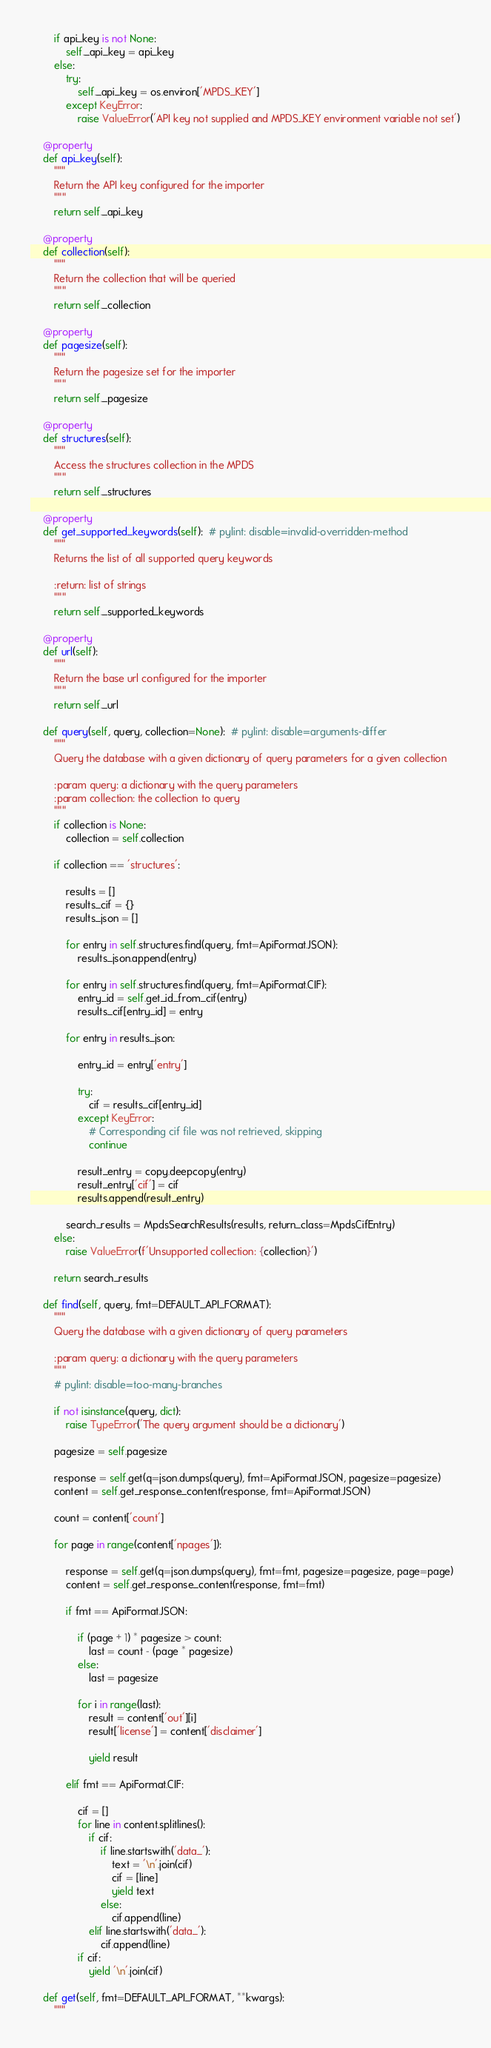<code> <loc_0><loc_0><loc_500><loc_500><_Python_>
        if api_key is not None:
            self._api_key = api_key
        else:
            try:
                self._api_key = os.environ['MPDS_KEY']
            except KeyError:
                raise ValueError('API key not supplied and MPDS_KEY environment variable not set')

    @property
    def api_key(self):
        """
        Return the API key configured for the importer
        """
        return self._api_key

    @property
    def collection(self):
        """
        Return the collection that will be queried
        """
        return self._collection

    @property
    def pagesize(self):
        """
        Return the pagesize set for the importer
        """
        return self._pagesize

    @property
    def structures(self):
        """
        Access the structures collection in the MPDS
        """
        return self._structures

    @property
    def get_supported_keywords(self):  # pylint: disable=invalid-overridden-method
        """
        Returns the list of all supported query keywords

        :return: list of strings
        """
        return self._supported_keywords

    @property
    def url(self):
        """
        Return the base url configured for the importer
        """
        return self._url

    def query(self, query, collection=None):  # pylint: disable=arguments-differ
        """
        Query the database with a given dictionary of query parameters for a given collection

        :param query: a dictionary with the query parameters
        :param collection: the collection to query
        """
        if collection is None:
            collection = self.collection

        if collection == 'structures':

            results = []
            results_cif = {}
            results_json = []

            for entry in self.structures.find(query, fmt=ApiFormat.JSON):
                results_json.append(entry)

            for entry in self.structures.find(query, fmt=ApiFormat.CIF):
                entry_id = self.get_id_from_cif(entry)
                results_cif[entry_id] = entry

            for entry in results_json:

                entry_id = entry['entry']

                try:
                    cif = results_cif[entry_id]
                except KeyError:
                    # Corresponding cif file was not retrieved, skipping
                    continue

                result_entry = copy.deepcopy(entry)
                result_entry['cif'] = cif
                results.append(result_entry)

            search_results = MpdsSearchResults(results, return_class=MpdsCifEntry)
        else:
            raise ValueError(f'Unsupported collection: {collection}')

        return search_results

    def find(self, query, fmt=DEFAULT_API_FORMAT):
        """
        Query the database with a given dictionary of query parameters

        :param query: a dictionary with the query parameters
        """
        # pylint: disable=too-many-branches

        if not isinstance(query, dict):
            raise TypeError('The query argument should be a dictionary')

        pagesize = self.pagesize

        response = self.get(q=json.dumps(query), fmt=ApiFormat.JSON, pagesize=pagesize)
        content = self.get_response_content(response, fmt=ApiFormat.JSON)

        count = content['count']

        for page in range(content['npages']):

            response = self.get(q=json.dumps(query), fmt=fmt, pagesize=pagesize, page=page)
            content = self.get_response_content(response, fmt=fmt)

            if fmt == ApiFormat.JSON:

                if (page + 1) * pagesize > count:
                    last = count - (page * pagesize)
                else:
                    last = pagesize

                for i in range(last):
                    result = content['out'][i]
                    result['license'] = content['disclaimer']

                    yield result

            elif fmt == ApiFormat.CIF:

                cif = []
                for line in content.splitlines():
                    if cif:
                        if line.startswith('data_'):
                            text = '\n'.join(cif)
                            cif = [line]
                            yield text
                        else:
                            cif.append(line)
                    elif line.startswith('data_'):
                        cif.append(line)
                if cif:
                    yield '\n'.join(cif)

    def get(self, fmt=DEFAULT_API_FORMAT, **kwargs):
        """</code> 